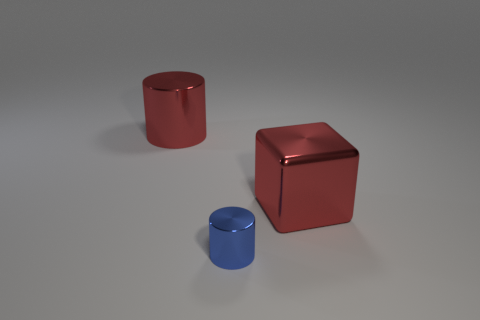What number of other small objects have the same color as the tiny shiny object?
Your response must be concise. 0. What size is the blue thing that is the same material as the big cube?
Provide a succinct answer. Small. What number of things are red objects that are on the right side of the blue metallic thing or red metal cubes?
Keep it short and to the point. 1. Does the shiny cylinder behind the small metallic thing have the same color as the small thing?
Make the answer very short. No. What is the size of the red thing that is the same shape as the blue thing?
Provide a short and direct response. Large. The cylinder that is behind the cylinder that is to the right of the large metallic object that is left of the tiny blue cylinder is what color?
Provide a succinct answer. Red. Do the small blue object and the red block have the same material?
Provide a succinct answer. Yes. There is a large shiny object that is to the right of the large red cylinder that is to the left of the blue metallic object; is there a cube that is in front of it?
Provide a short and direct response. No. Does the big cylinder have the same color as the block?
Ensure brevity in your answer.  Yes. Is the number of small blue things less than the number of big red objects?
Your answer should be very brief. Yes. 